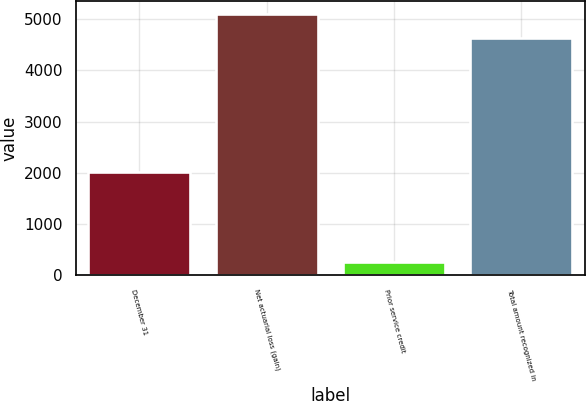<chart> <loc_0><loc_0><loc_500><loc_500><bar_chart><fcel>December 31<fcel>Net actuarial loss (gain)<fcel>Prior service credit<fcel>Total amount recognized in<nl><fcel>2015<fcel>5091.9<fcel>258<fcel>4629<nl></chart> 